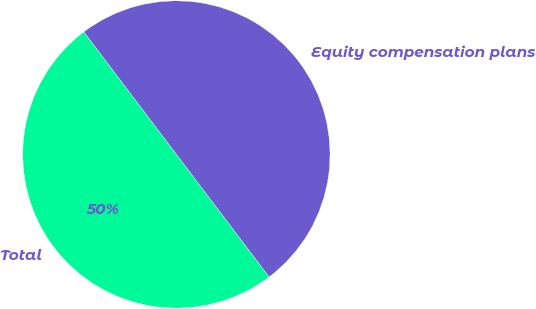Convert chart. <chart><loc_0><loc_0><loc_500><loc_500><pie_chart><fcel>Equity compensation plans<fcel>Total<nl><fcel>50.0%<fcel>50.0%<nl></chart> 